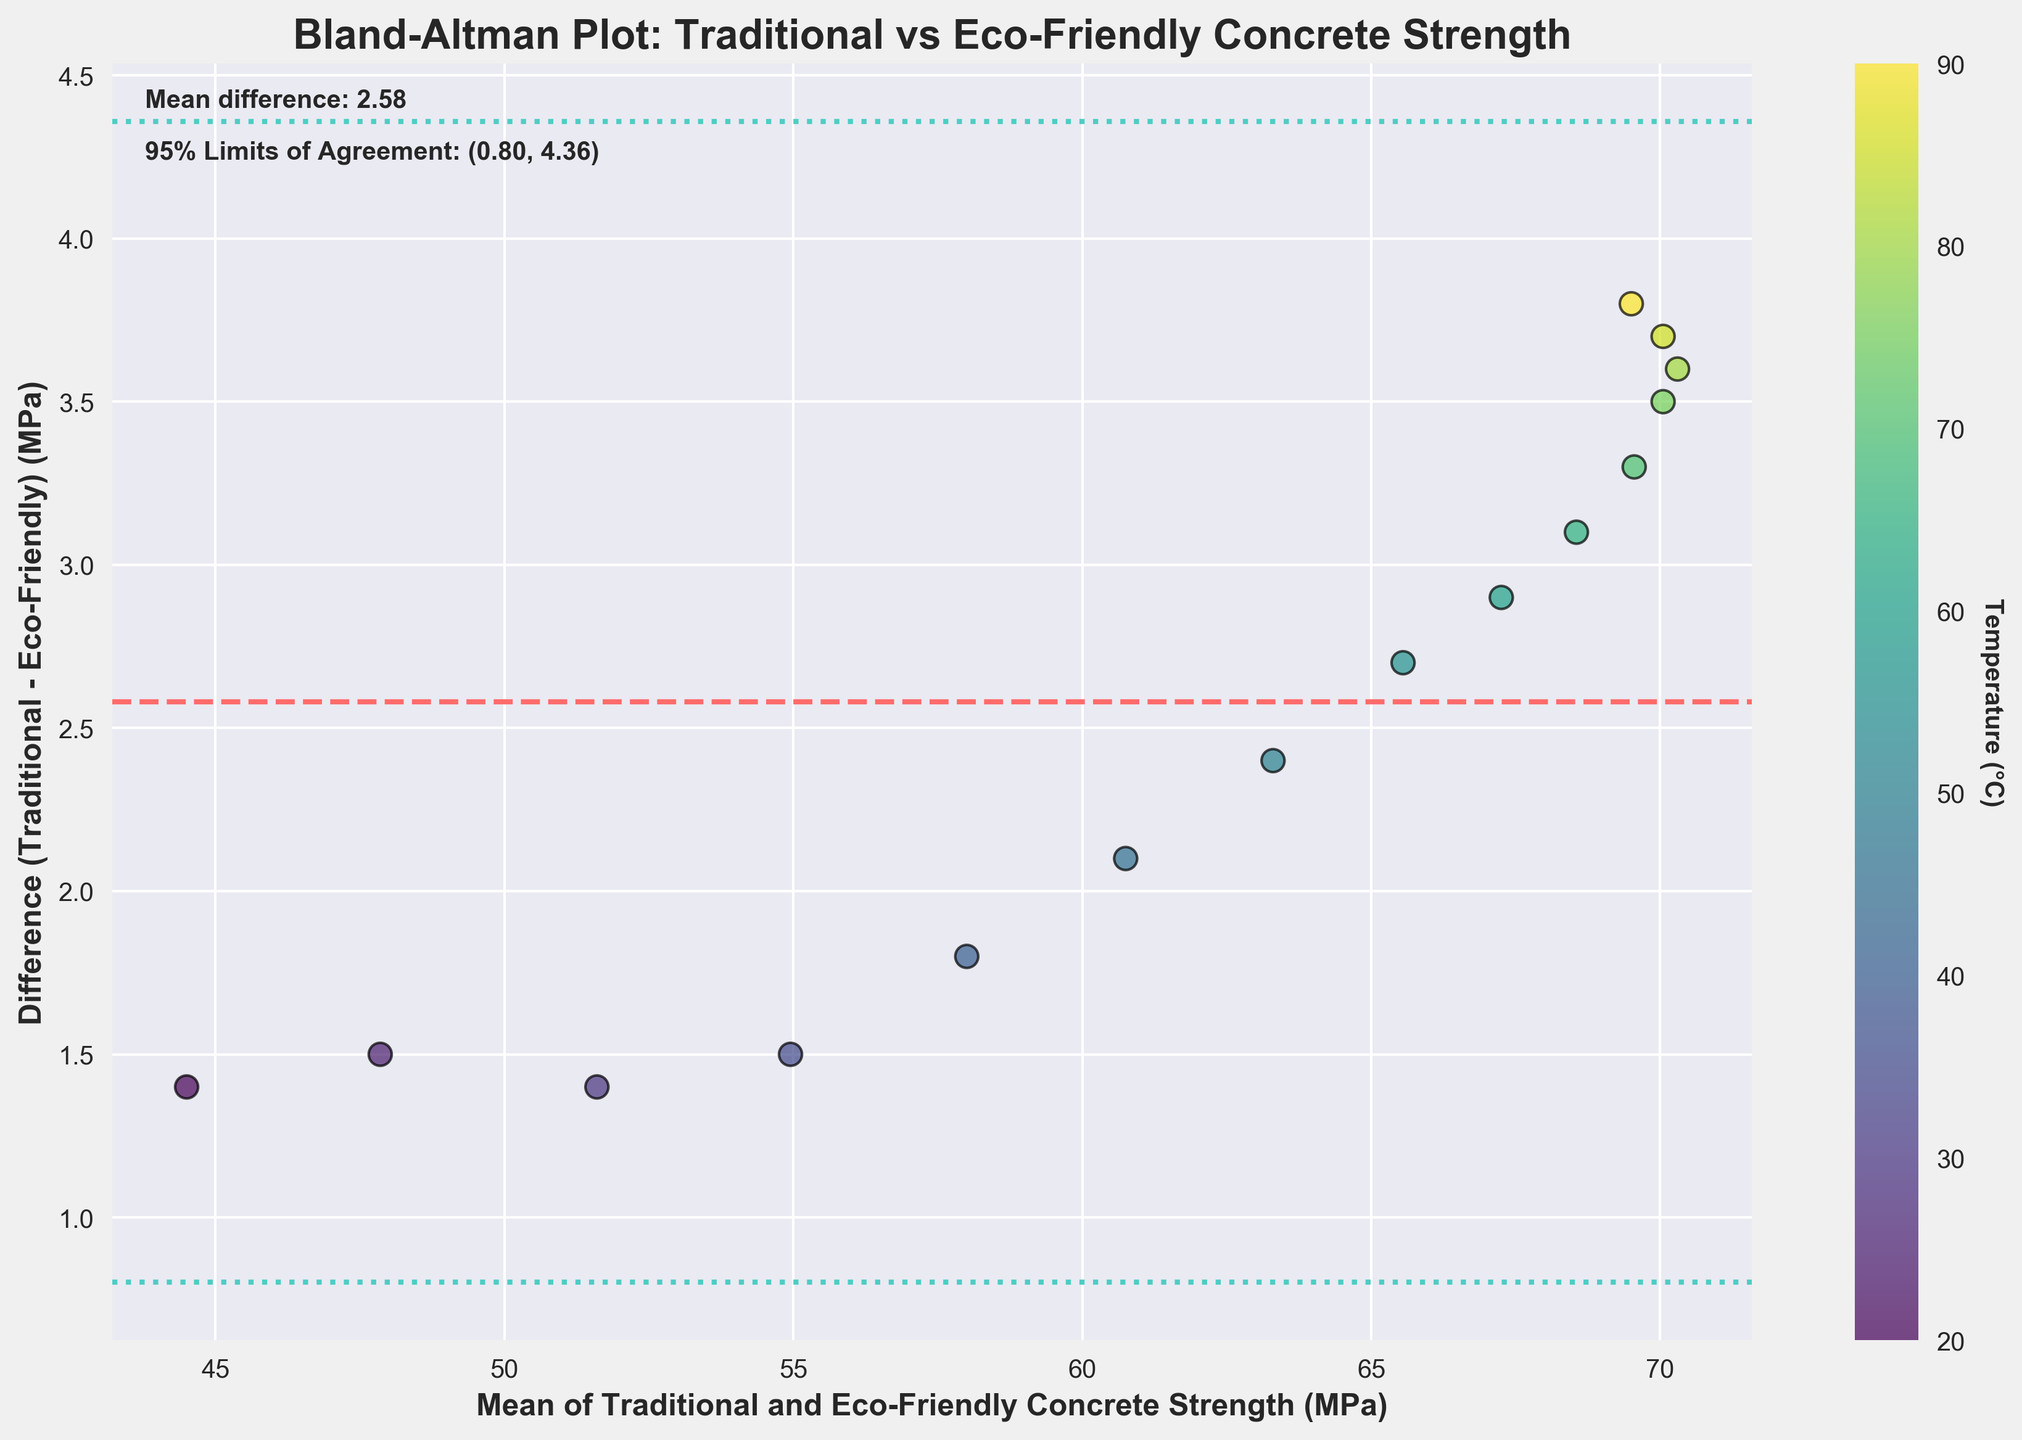How many data points are plotted in the figure? The figure has 15 data points representing the concrete strength differences measured at different temperatures.
Answer: 15 What is the title of the figure? The title is displayed at the top of the figure. It is "Bland-Altman Plot: Traditional vs Eco-Friendly Concrete Strength".
Answer: Bland-Altman Plot: Traditional vs Eco-Friendly Concrete Strength Which color is used to represent temperature in the figure? The figure uses a color gradient to represent temperature, shown by the color bar on the right-hand side. The colors range from yellow to green.
Answer: Yellow to green What's the mean difference between traditional and eco-friendly concrete strength? The mean difference is mentioned in the text in the top left corner of the plot. It is "Mean difference: 3.09".
Answer: 3.09 What are the 95% limits of agreement for the concrete strength differences? The 95% limits of agreement are displayed in the text in the top left corner of the plot. They are "(-0.31, 6.49)".
Answer: (-0.31, 6.49) Which data point shows the smallest difference between traditional and eco-friendly concrete by strength? The smallest difference can be found by locating the point closest to zero on the vertical axis. The point at a mean strength of about 72 has the smallest difference.
Answer: Mean strength around 72 MPa Which temperature corresponds to the largest positive difference between the traditional and eco-friendly concrete strength? The data point with the largest positive difference is located at the topmost position on the plot. Using the color gradient, this point corresponds to a temperature of 60°C.
Answer: 60°C Is there any temperature point where the difference is negative? Negative differences occur when the points are below the zero line on the vertical axis. The data point with the negative difference corresponds to a mean strength around 50 MPa.
Answer: Yes Which concrete type has generally higher strength based on the plot? Since most differences are positive (above the zero line), it indicates that traditional concrete has generally higher strength compared to the eco-friendly formula.
Answer: Traditional concrete Does the difference in concrete strength change consistently with the temperature? By observing the scatter plot, there seems to be no consistent pattern of the difference changing with temperature as the points are scattered without forming a specific trend.
Answer: No 